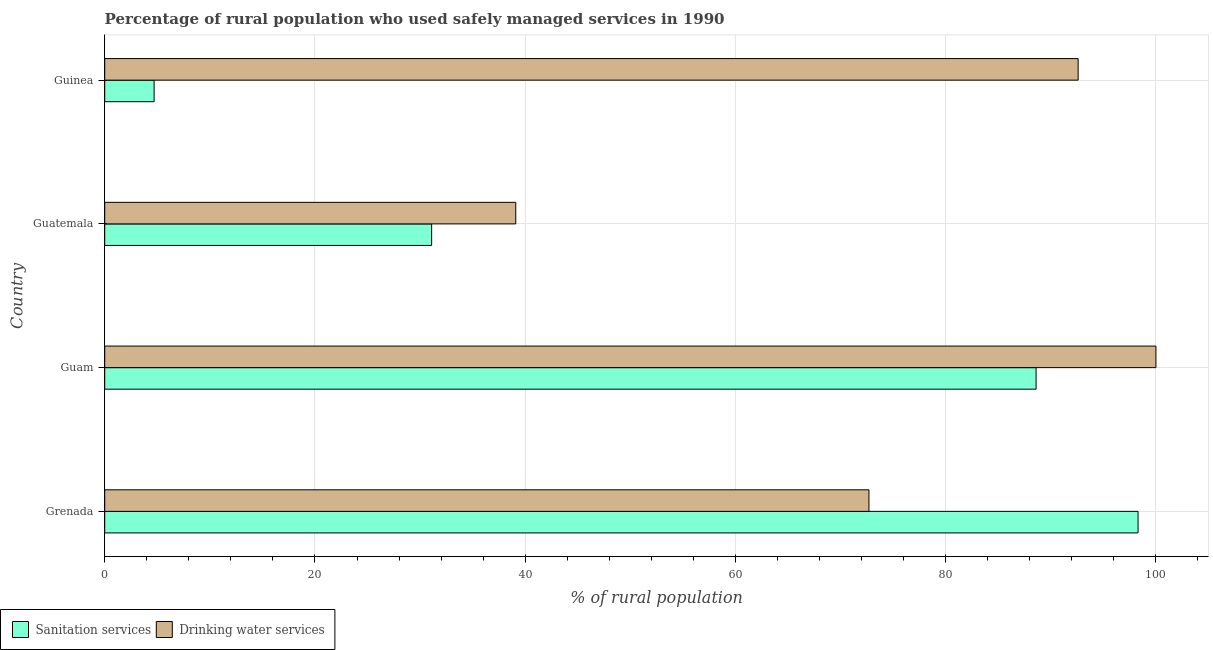How many groups of bars are there?
Keep it short and to the point. 4. What is the label of the 1st group of bars from the top?
Offer a terse response. Guinea. In how many cases, is the number of bars for a given country not equal to the number of legend labels?
Keep it short and to the point. 0. What is the percentage of rural population who used sanitation services in Guam?
Keep it short and to the point. 88.6. Across all countries, what is the maximum percentage of rural population who used sanitation services?
Offer a very short reply. 98.3. Across all countries, what is the minimum percentage of rural population who used sanitation services?
Keep it short and to the point. 4.7. In which country was the percentage of rural population who used drinking water services maximum?
Ensure brevity in your answer.  Guam. In which country was the percentage of rural population who used drinking water services minimum?
Offer a very short reply. Guatemala. What is the total percentage of rural population who used sanitation services in the graph?
Provide a succinct answer. 222.7. What is the difference between the percentage of rural population who used sanitation services in Guatemala and that in Guinea?
Provide a succinct answer. 26.4. What is the difference between the percentage of rural population who used sanitation services in Guatemala and the percentage of rural population who used drinking water services in Guinea?
Give a very brief answer. -61.5. What is the average percentage of rural population who used sanitation services per country?
Provide a succinct answer. 55.67. What is the difference between the percentage of rural population who used drinking water services and percentage of rural population who used sanitation services in Guam?
Provide a short and direct response. 11.4. In how many countries, is the percentage of rural population who used drinking water services greater than 96 %?
Offer a very short reply. 1. What is the ratio of the percentage of rural population who used sanitation services in Grenada to that in Guatemala?
Ensure brevity in your answer.  3.16. Is the percentage of rural population who used drinking water services in Grenada less than that in Guinea?
Give a very brief answer. Yes. Is the difference between the percentage of rural population who used sanitation services in Grenada and Guam greater than the difference between the percentage of rural population who used drinking water services in Grenada and Guam?
Provide a succinct answer. Yes. What is the difference between the highest and the second highest percentage of rural population who used sanitation services?
Give a very brief answer. 9.7. What is the difference between the highest and the lowest percentage of rural population who used sanitation services?
Offer a terse response. 93.6. Is the sum of the percentage of rural population who used drinking water services in Grenada and Guinea greater than the maximum percentage of rural population who used sanitation services across all countries?
Provide a succinct answer. Yes. What does the 1st bar from the top in Guatemala represents?
Offer a very short reply. Drinking water services. What does the 1st bar from the bottom in Guam represents?
Your response must be concise. Sanitation services. How many bars are there?
Ensure brevity in your answer.  8. Are all the bars in the graph horizontal?
Give a very brief answer. Yes. How many countries are there in the graph?
Give a very brief answer. 4. What is the difference between two consecutive major ticks on the X-axis?
Offer a terse response. 20. Does the graph contain any zero values?
Your answer should be very brief. No. Does the graph contain grids?
Offer a terse response. Yes. Where does the legend appear in the graph?
Ensure brevity in your answer.  Bottom left. How are the legend labels stacked?
Offer a very short reply. Horizontal. What is the title of the graph?
Offer a very short reply. Percentage of rural population who used safely managed services in 1990. Does "GDP at market prices" appear as one of the legend labels in the graph?
Offer a terse response. No. What is the label or title of the X-axis?
Provide a short and direct response. % of rural population. What is the label or title of the Y-axis?
Make the answer very short. Country. What is the % of rural population in Sanitation services in Grenada?
Provide a short and direct response. 98.3. What is the % of rural population of Drinking water services in Grenada?
Your answer should be very brief. 72.7. What is the % of rural population of Sanitation services in Guam?
Give a very brief answer. 88.6. What is the % of rural population of Sanitation services in Guatemala?
Offer a terse response. 31.1. What is the % of rural population of Drinking water services in Guatemala?
Offer a very short reply. 39.1. What is the % of rural population in Sanitation services in Guinea?
Give a very brief answer. 4.7. What is the % of rural population in Drinking water services in Guinea?
Make the answer very short. 92.6. Across all countries, what is the maximum % of rural population in Sanitation services?
Offer a very short reply. 98.3. Across all countries, what is the minimum % of rural population of Sanitation services?
Offer a very short reply. 4.7. Across all countries, what is the minimum % of rural population of Drinking water services?
Your answer should be very brief. 39.1. What is the total % of rural population of Sanitation services in the graph?
Make the answer very short. 222.7. What is the total % of rural population in Drinking water services in the graph?
Your answer should be very brief. 304.4. What is the difference between the % of rural population in Sanitation services in Grenada and that in Guam?
Give a very brief answer. 9.7. What is the difference between the % of rural population in Drinking water services in Grenada and that in Guam?
Keep it short and to the point. -27.3. What is the difference between the % of rural population of Sanitation services in Grenada and that in Guatemala?
Keep it short and to the point. 67.2. What is the difference between the % of rural population of Drinking water services in Grenada and that in Guatemala?
Offer a very short reply. 33.6. What is the difference between the % of rural population of Sanitation services in Grenada and that in Guinea?
Provide a short and direct response. 93.6. What is the difference between the % of rural population of Drinking water services in Grenada and that in Guinea?
Your answer should be compact. -19.9. What is the difference between the % of rural population of Sanitation services in Guam and that in Guatemala?
Ensure brevity in your answer.  57.5. What is the difference between the % of rural population of Drinking water services in Guam and that in Guatemala?
Your answer should be compact. 60.9. What is the difference between the % of rural population in Sanitation services in Guam and that in Guinea?
Give a very brief answer. 83.9. What is the difference between the % of rural population of Sanitation services in Guatemala and that in Guinea?
Provide a short and direct response. 26.4. What is the difference between the % of rural population of Drinking water services in Guatemala and that in Guinea?
Your response must be concise. -53.5. What is the difference between the % of rural population in Sanitation services in Grenada and the % of rural population in Drinking water services in Guatemala?
Ensure brevity in your answer.  59.2. What is the difference between the % of rural population in Sanitation services in Grenada and the % of rural population in Drinking water services in Guinea?
Keep it short and to the point. 5.7. What is the difference between the % of rural population in Sanitation services in Guam and the % of rural population in Drinking water services in Guatemala?
Give a very brief answer. 49.5. What is the difference between the % of rural population in Sanitation services in Guatemala and the % of rural population in Drinking water services in Guinea?
Ensure brevity in your answer.  -61.5. What is the average % of rural population in Sanitation services per country?
Give a very brief answer. 55.67. What is the average % of rural population of Drinking water services per country?
Keep it short and to the point. 76.1. What is the difference between the % of rural population of Sanitation services and % of rural population of Drinking water services in Grenada?
Offer a very short reply. 25.6. What is the difference between the % of rural population of Sanitation services and % of rural population of Drinking water services in Guatemala?
Keep it short and to the point. -8. What is the difference between the % of rural population of Sanitation services and % of rural population of Drinking water services in Guinea?
Make the answer very short. -87.9. What is the ratio of the % of rural population in Sanitation services in Grenada to that in Guam?
Offer a terse response. 1.11. What is the ratio of the % of rural population in Drinking water services in Grenada to that in Guam?
Ensure brevity in your answer.  0.73. What is the ratio of the % of rural population of Sanitation services in Grenada to that in Guatemala?
Make the answer very short. 3.16. What is the ratio of the % of rural population in Drinking water services in Grenada to that in Guatemala?
Provide a short and direct response. 1.86. What is the ratio of the % of rural population in Sanitation services in Grenada to that in Guinea?
Provide a succinct answer. 20.91. What is the ratio of the % of rural population in Drinking water services in Grenada to that in Guinea?
Your answer should be compact. 0.79. What is the ratio of the % of rural population in Sanitation services in Guam to that in Guatemala?
Offer a terse response. 2.85. What is the ratio of the % of rural population in Drinking water services in Guam to that in Guatemala?
Your response must be concise. 2.56. What is the ratio of the % of rural population of Sanitation services in Guam to that in Guinea?
Provide a succinct answer. 18.85. What is the ratio of the % of rural population of Drinking water services in Guam to that in Guinea?
Keep it short and to the point. 1.08. What is the ratio of the % of rural population of Sanitation services in Guatemala to that in Guinea?
Provide a short and direct response. 6.62. What is the ratio of the % of rural population of Drinking water services in Guatemala to that in Guinea?
Give a very brief answer. 0.42. What is the difference between the highest and the lowest % of rural population in Sanitation services?
Offer a very short reply. 93.6. What is the difference between the highest and the lowest % of rural population of Drinking water services?
Your answer should be compact. 60.9. 